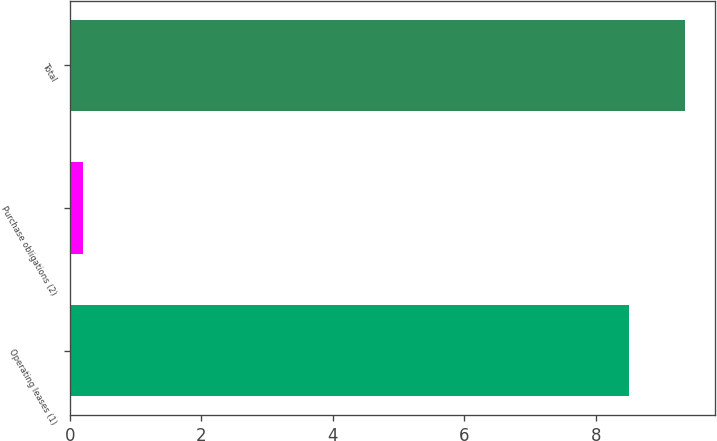Convert chart. <chart><loc_0><loc_0><loc_500><loc_500><bar_chart><fcel>Operating leases (1)<fcel>Purchase obligations (2)<fcel>Total<nl><fcel>8.5<fcel>0.2<fcel>9.35<nl></chart> 